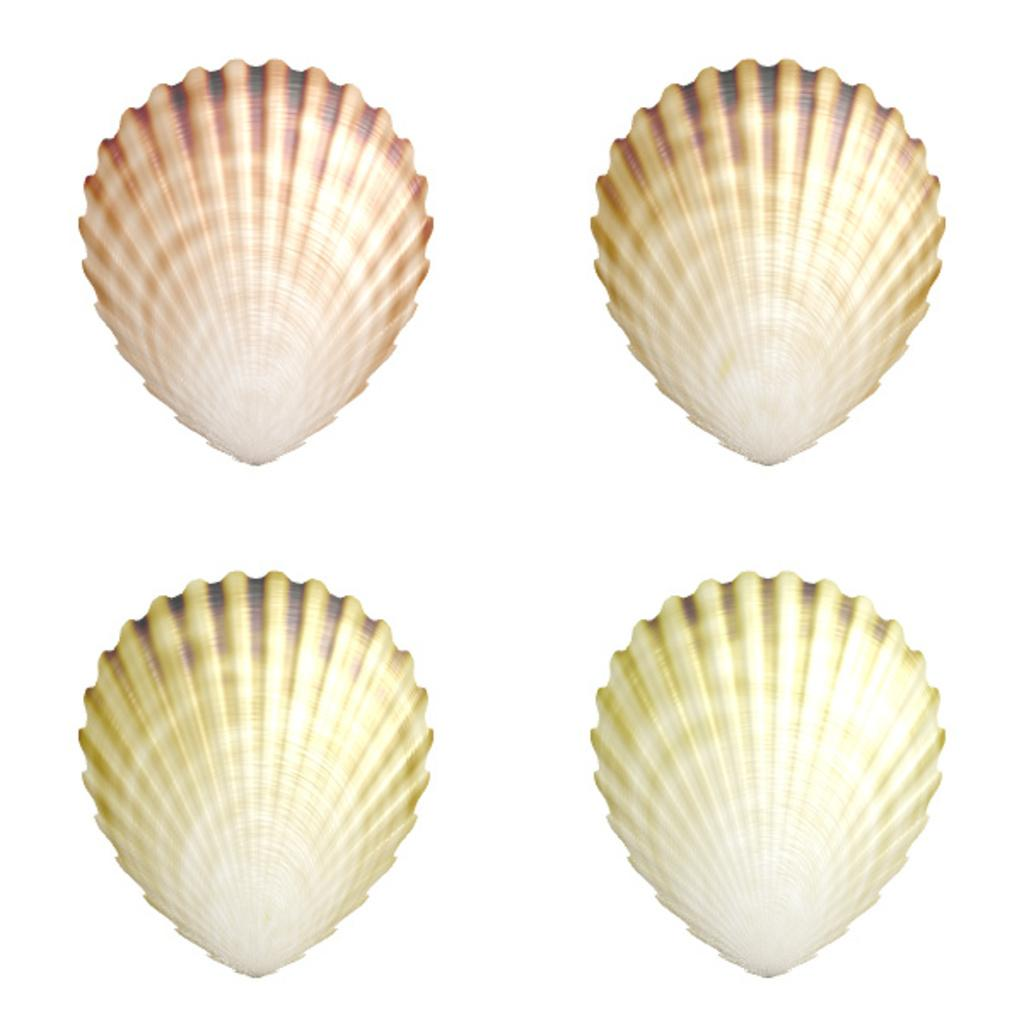How many shells are present in the image? There are four shells in the image. What can be seen in the background of the image? The background of the image is white. What advice does the mom give about the shells in the image? There is no mom present in the image, and therefore no advice can be given about the shells. 